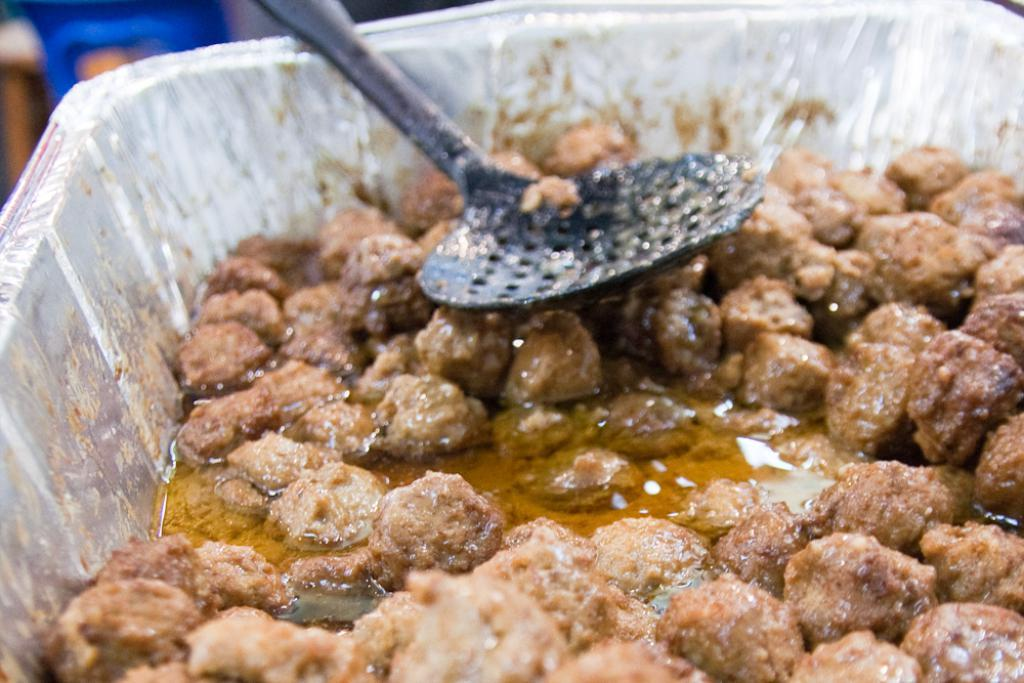What is the main subject of the image? There is a food item in the image. How is the food item contained or packaged? The food item is in a box. What tool or instrument is present in the image? There is a utensil in the image. What type of tax is being discussed in the image? There is no mention of tax in the image; it features a food item in a box and a utensil. Is there a throne present in the image? No, there is no throne present in the image. 